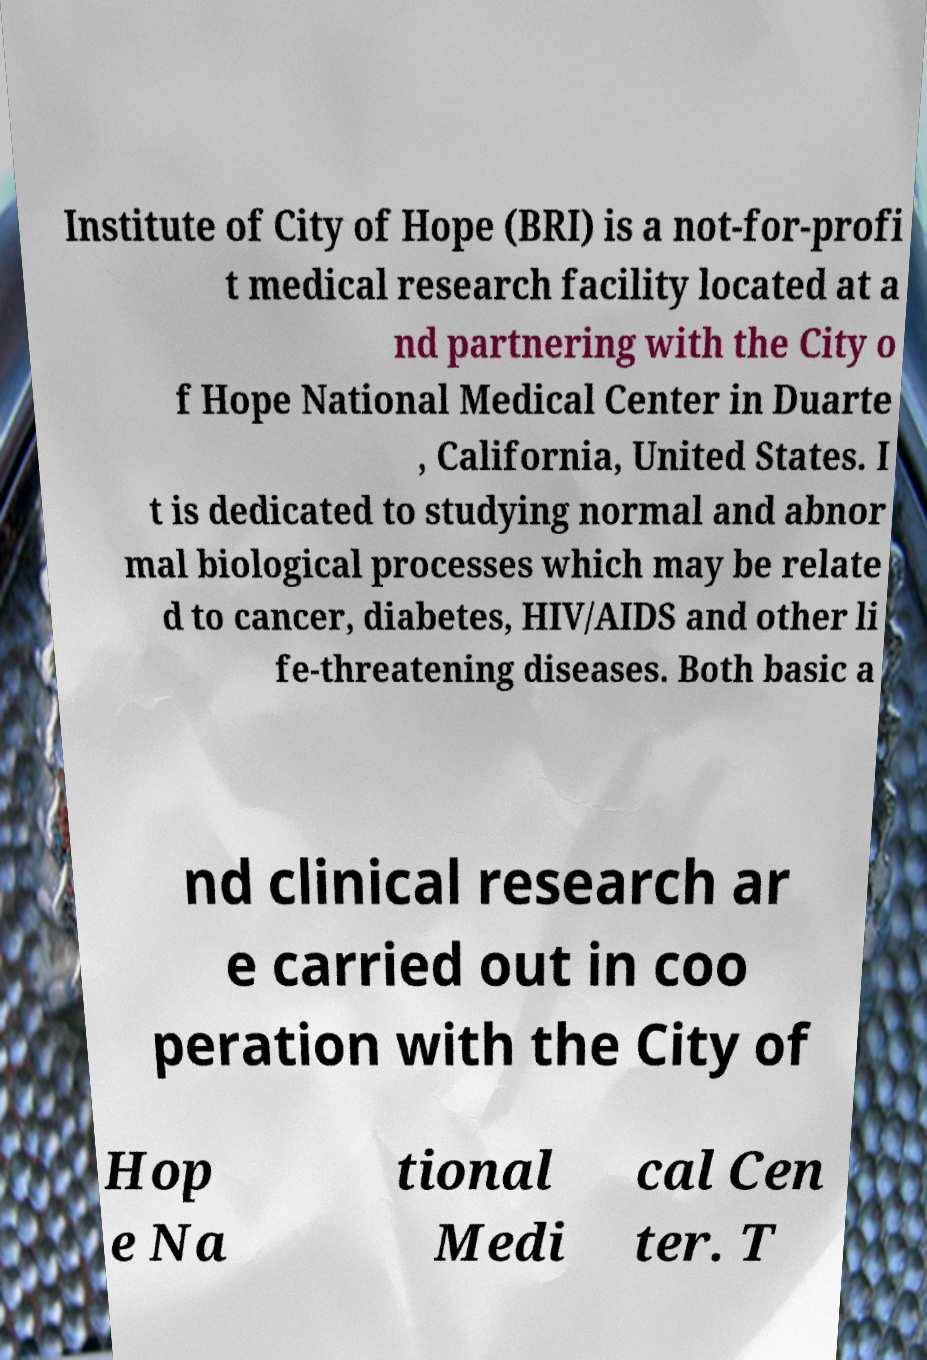There's text embedded in this image that I need extracted. Can you transcribe it verbatim? Institute of City of Hope (BRI) is a not-for-profi t medical research facility located at a nd partnering with the City o f Hope National Medical Center in Duarte , California, United States. I t is dedicated to studying normal and abnor mal biological processes which may be relate d to cancer, diabetes, HIV/AIDS and other li fe-threatening diseases. Both basic a nd clinical research ar e carried out in coo peration with the City of Hop e Na tional Medi cal Cen ter. T 